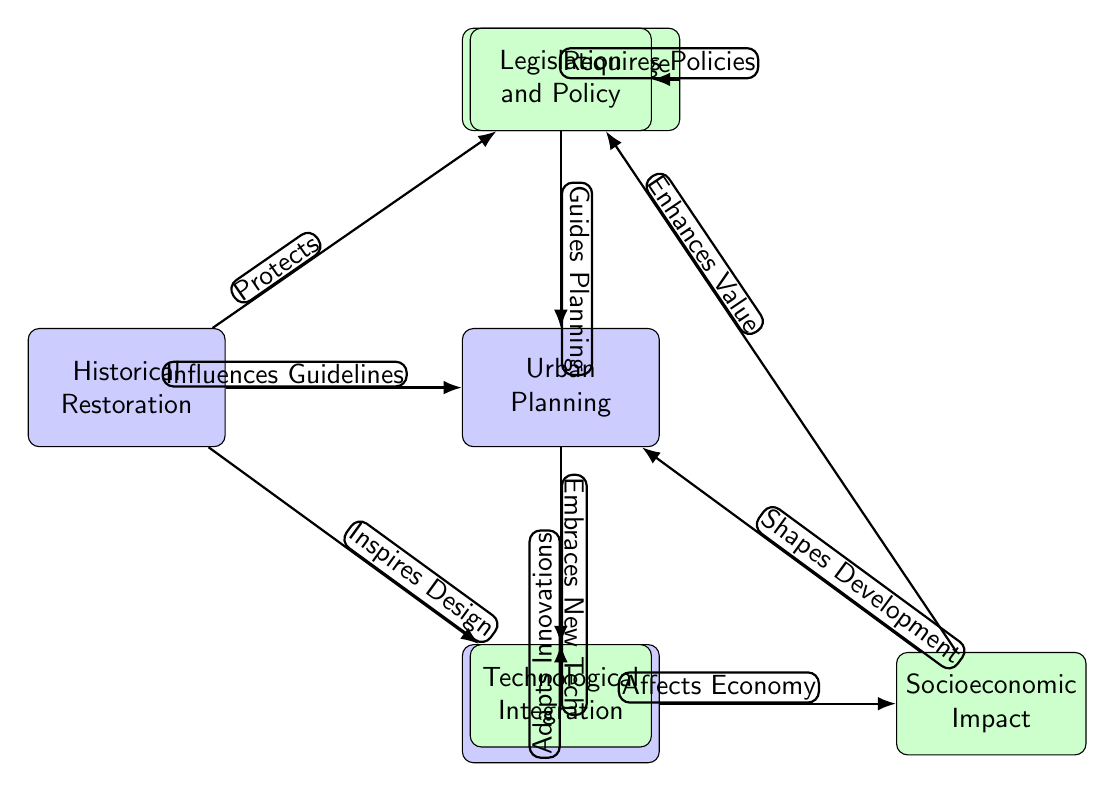What is the main node at the top left? The diagram indicates that the main node at the top left is "Historical Restoration." This is confirmed by identifying the node which is the starting point of the diagram layout.
Answer: Historical Restoration How many secondary nodes are present? By counting the nodes labeled as "secondary," I find there are four secondary nodes listed: "Cultural Heritage Preservation," "Technological Integration," "Legislation and Policy," and "Socioeconomic Impact." Therefore, the total is four.
Answer: 4 What does the "Historical Restoration" node protect? The edge labeled "Protects" indicates that "Historical Restoration" protects "Cultural Heritage Preservation." This specifies the direct relationship between the two nodes.
Answer: Cultural Heritage Preservation Which node guides urban planning? The edge labeled "Guides Planning" connects "Legislation and Policy" to "Urban Planning," showing that the latter is guided by the former. This identifies the influencing relationship between these two specific nodes.
Answer: Legislation and Policy What does "Modern Architecture" adapt according to the diagram? The edge labeled "Adapts Innovations" shows that "Modern Architecture" adapts to "Technological Integration." This specifically highlights how modern practices in architecture respond to advancements in technology.
Answer: Technological Integration How does "Cultural Heritage Preservation" enhance urban planning? The edge labeled "Enhances Value" shows that "Socioeconomic Impact" enhances "Cultural Heritage Preservation." This implies that the socioeconomic conditions contribute positively to the preservation efforts, thereby enriching the overall urban planning.
Answer: Socioeconomic Impact What does "Modern Architecture" inspire according to the diagram? The edge labeled "Inspires Design" reveals that "Historical Restoration" inspires "Modern Architecture." This indicates that restoration efforts influenced contemporary architectural designs.
Answer: Modern Architecture Which node is affected by the economy? The edge labeled "Affects Economy" links "Modern Architecture" to "Socioeconomic Impact," indicating that modern architectural practices have an effect on economic conditions, thus highlighting an interconnection between these two areas.
Answer: Socioeconomic Impact How many edges are connected to "Urban Planning"? By counting the edges connecting to the node labeled "Urban Planning," we see three connections: from "Historical Restoration," "Legislation and Policy," and "Socioeconomic Impact." This informs us about the interactions involving urban planning.
Answer: 3 